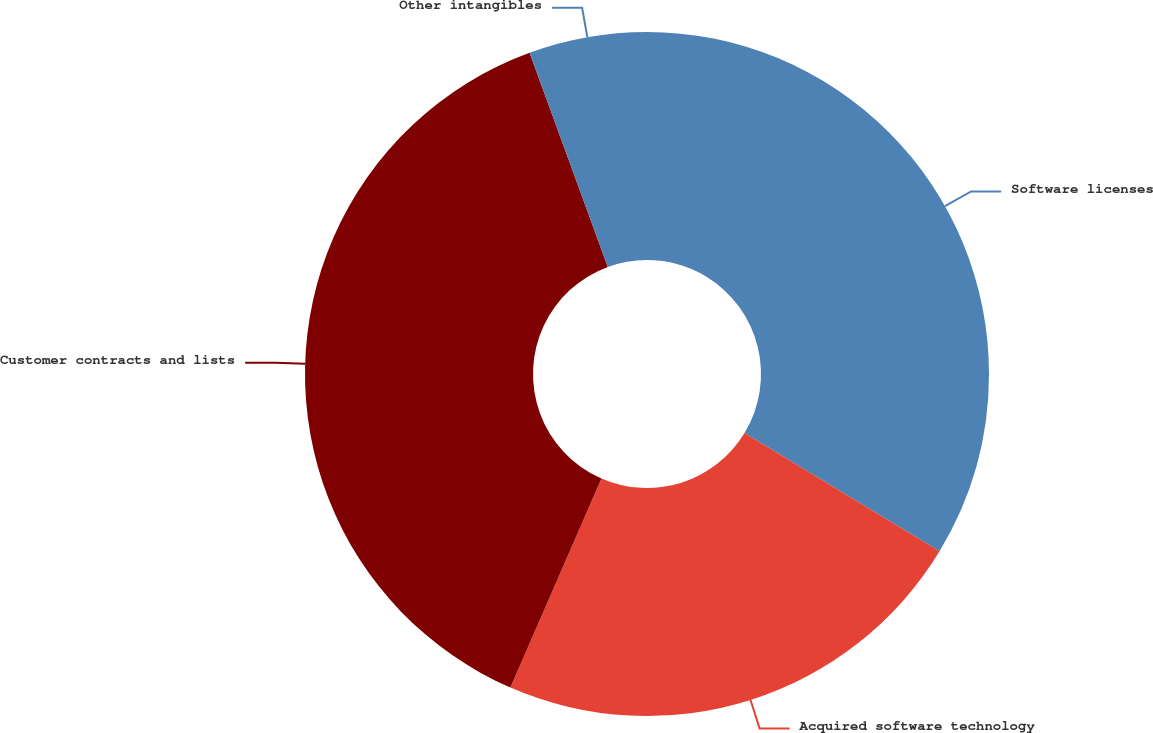Convert chart to OTSL. <chart><loc_0><loc_0><loc_500><loc_500><pie_chart><fcel>Software licenses<fcel>Acquired software technology<fcel>Customer contracts and lists<fcel>Other intangibles<nl><fcel>33.67%<fcel>22.87%<fcel>37.88%<fcel>5.58%<nl></chart> 